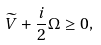Convert formula to latex. <formula><loc_0><loc_0><loc_500><loc_500>\widetilde { V } + \frac { i } { 2 } \Omega \geq 0 ,</formula> 